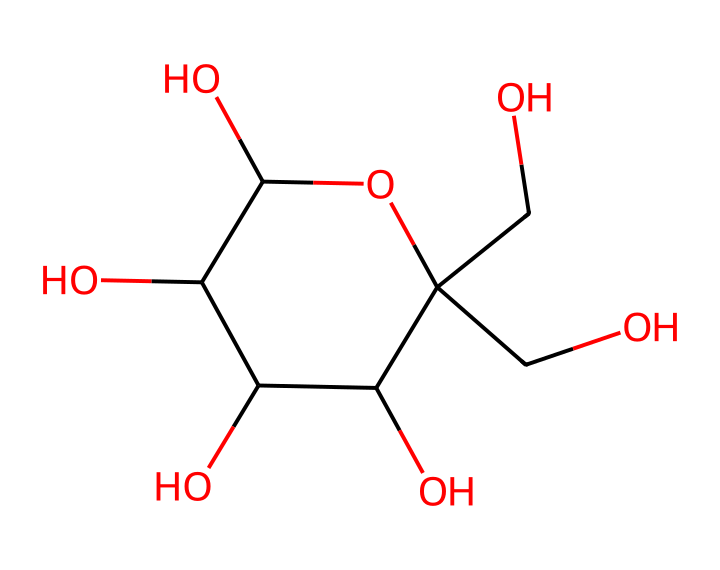What is the name of this chemical? The SMILES representation corresponds to fructose, which is a specific type of sugar commonly found in fruits. In the structure, the ring formation and hydroxyl groups indicate it is a monosaccharide known as fructose.
Answer: fructose How many carbon atoms are in this molecule? By analyzing the SMILES representation, we can count the number of carbon (C) symbols present, which indicates the number of carbon atoms in the structure. In this case, there are 6 carbon atoms.
Answer: 6 What type of carbohydrate is fructose classified as? Fructose is classified as a simple sugar or monosaccharide because it consists of a single sugar unit, which is a characteristic of monosaccharides as opposed to polysaccharides or disaccharides.
Answer: monosaccharide How many hydroxyl (–OH) groups are present in this molecule? The SMILES structure indicates the presence of hydroxyl groups, identifiable by the "O" and attached "H" symbols. Counting these groups reveals there are 5 hydroxyl groups in the fructose structure.
Answer: 5 What form does the carbon backbone of fructose take? The arrangement in the SMILES indicates a cyclic structure with a pentagonal arrangement of carbon atoms due to the nature of fructose as a furanose form, confirming that its carbons are arranged in a ring shape.
Answer: ring Is fructose a reducing sugar? Yes, fructose is a reducing sugar because it has a free aldehyde or ketone group which can reduce other compounds. This characteristic is evident from its structural representation, where such functional groups can interact chemically in solutions.
Answer: yes 